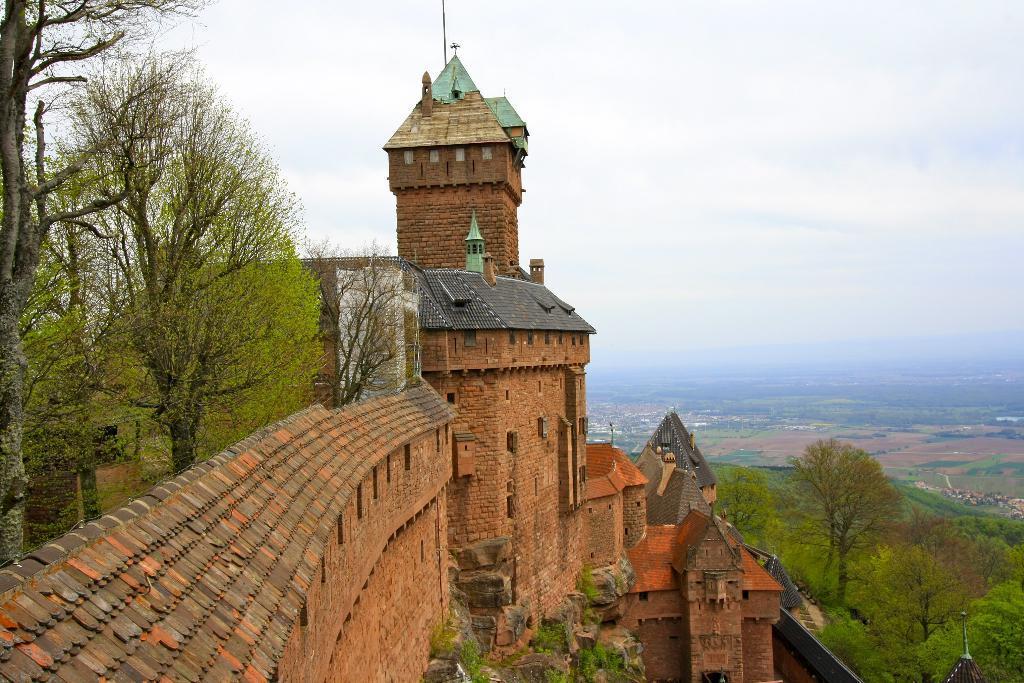How would you summarize this image in a sentence or two? In this image we can see the building, there are trees at behind and in front of the building and sky in the background. 